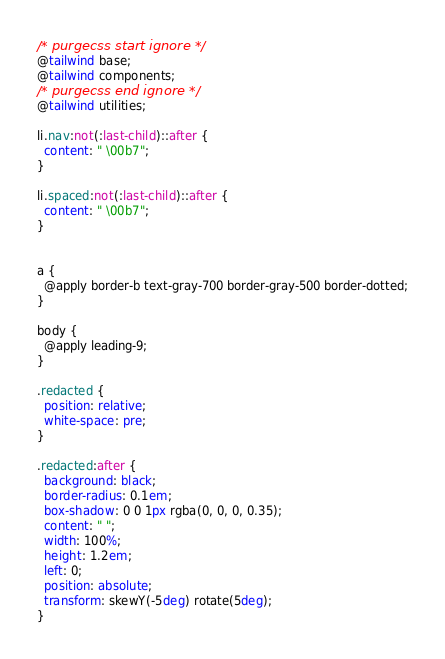<code> <loc_0><loc_0><loc_500><loc_500><_CSS_>/* purgecss start ignore */
@tailwind base;
@tailwind components;
/* purgecss end ignore */
@tailwind utilities;

li.nav:not(:last-child)::after {
  content: " \00b7";
}

li.spaced:not(:last-child)::after {
  content: " \00b7";
}


a {
  @apply border-b text-gray-700 border-gray-500 border-dotted;
}

body {
  @apply leading-9;
}

.redacted {
  position: relative;
  white-space: pre;
}

.redacted:after {
  background: black;
  border-radius: 0.1em;
  box-shadow: 0 0 1px rgba(0, 0, 0, 0.35);
  content: " ";
  width: 100%;
  height: 1.2em;
  left: 0;
  position: absolute;
  transform: skewY(-5deg) rotate(5deg);
}
</code> 